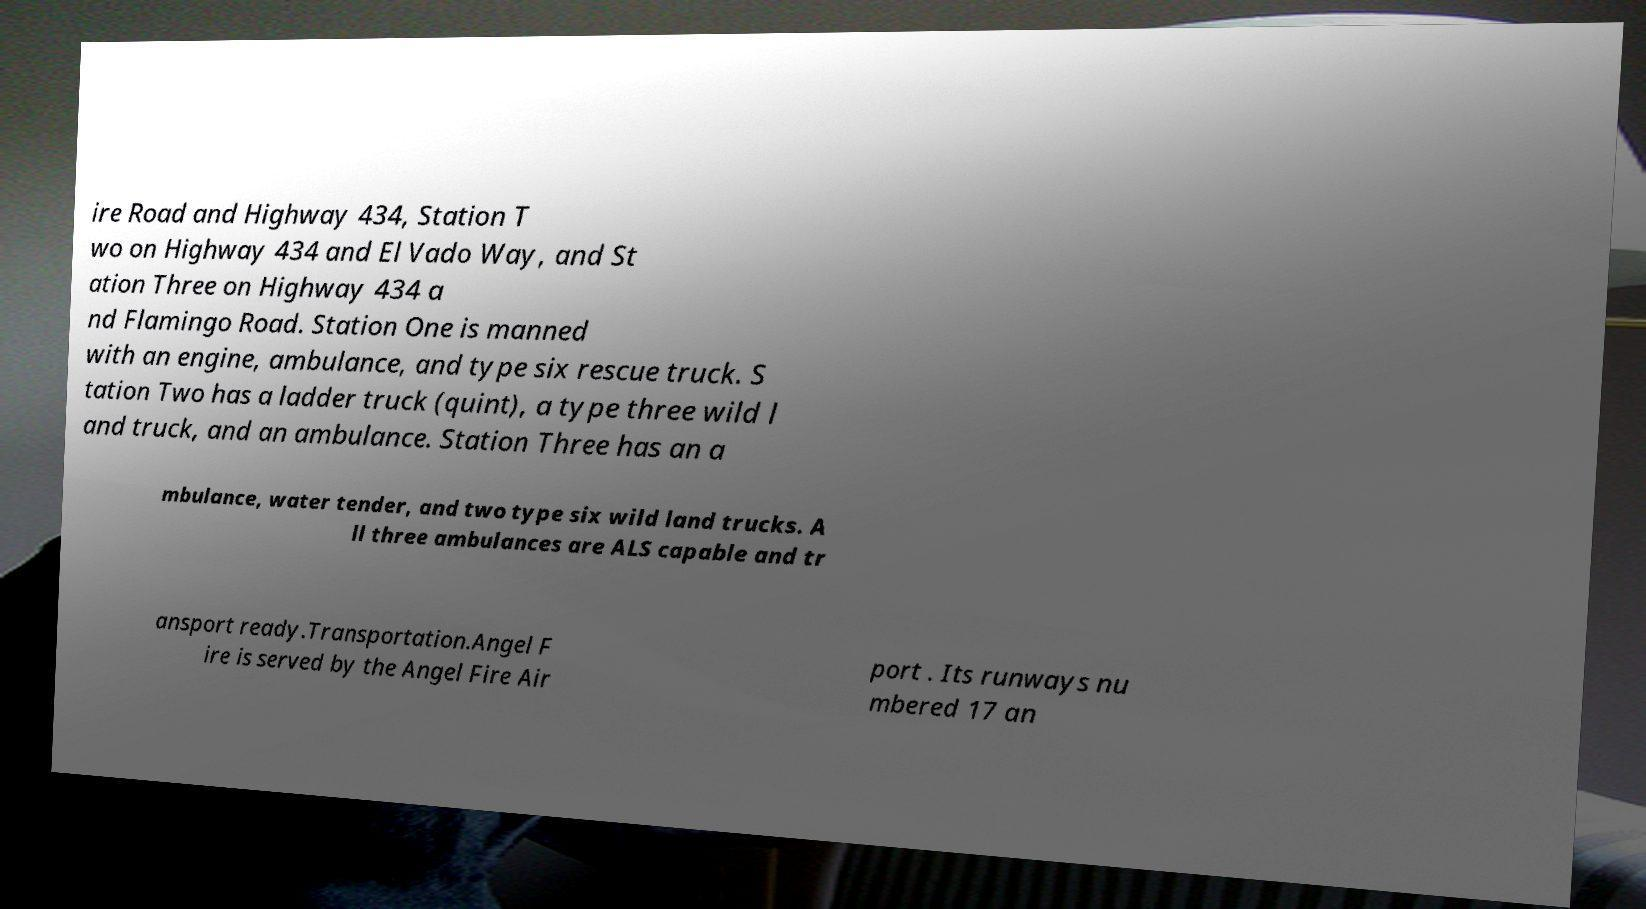Can you read and provide the text displayed in the image?This photo seems to have some interesting text. Can you extract and type it out for me? ire Road and Highway 434, Station T wo on Highway 434 and El Vado Way, and St ation Three on Highway 434 a nd Flamingo Road. Station One is manned with an engine, ambulance, and type six rescue truck. S tation Two has a ladder truck (quint), a type three wild l and truck, and an ambulance. Station Three has an a mbulance, water tender, and two type six wild land trucks. A ll three ambulances are ALS capable and tr ansport ready.Transportation.Angel F ire is served by the Angel Fire Air port . Its runways nu mbered 17 an 